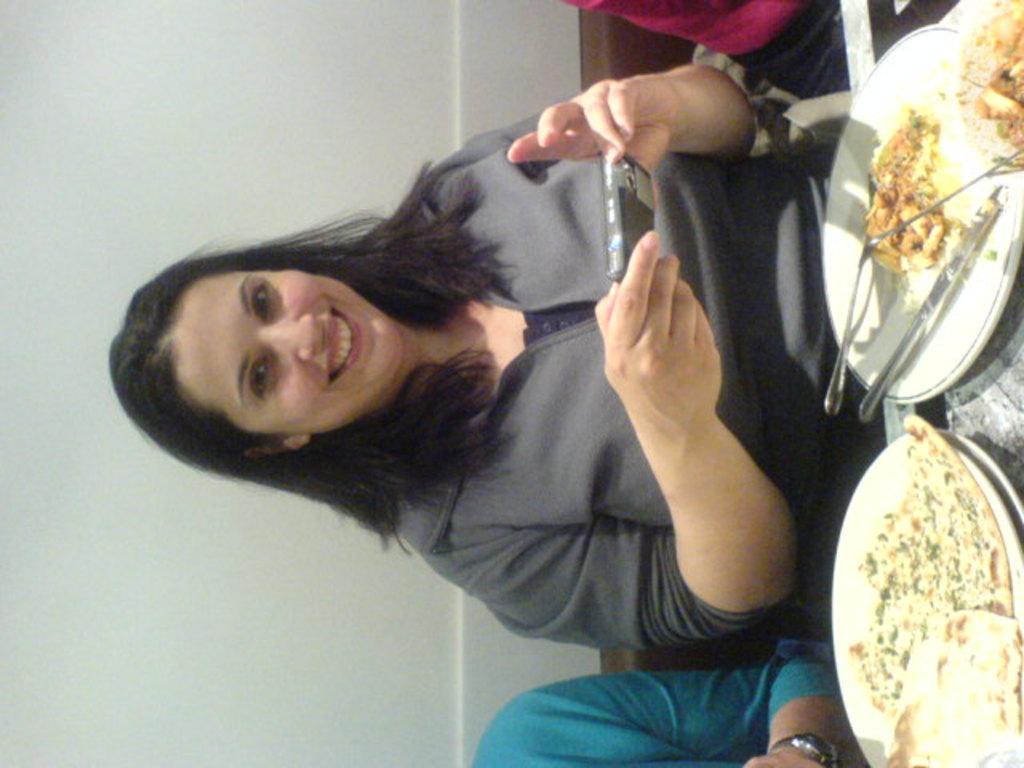In one or two sentences, can you explain what this image depicts? In the center of the image there is a lady holding a phone in her hands. In front of her there is a plate there is some food item in it. In the background of the image there is a wall. 